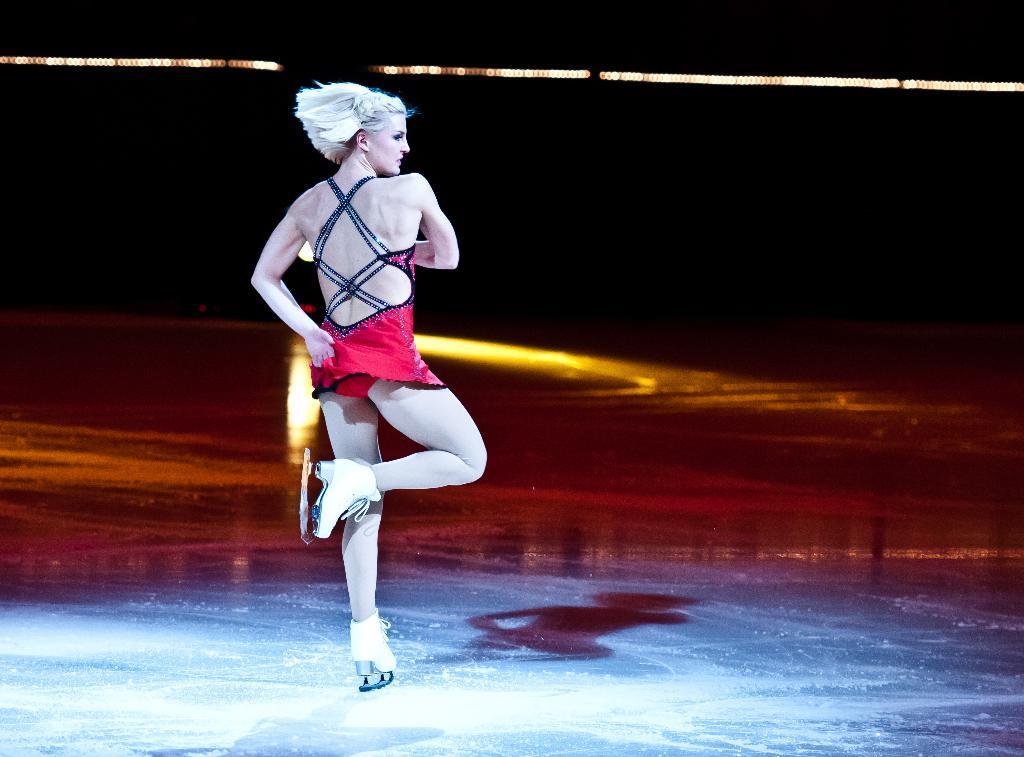In one or two sentences, can you explain what this image depicts? Here we can see a woman and there are lights. There is a dark background. 